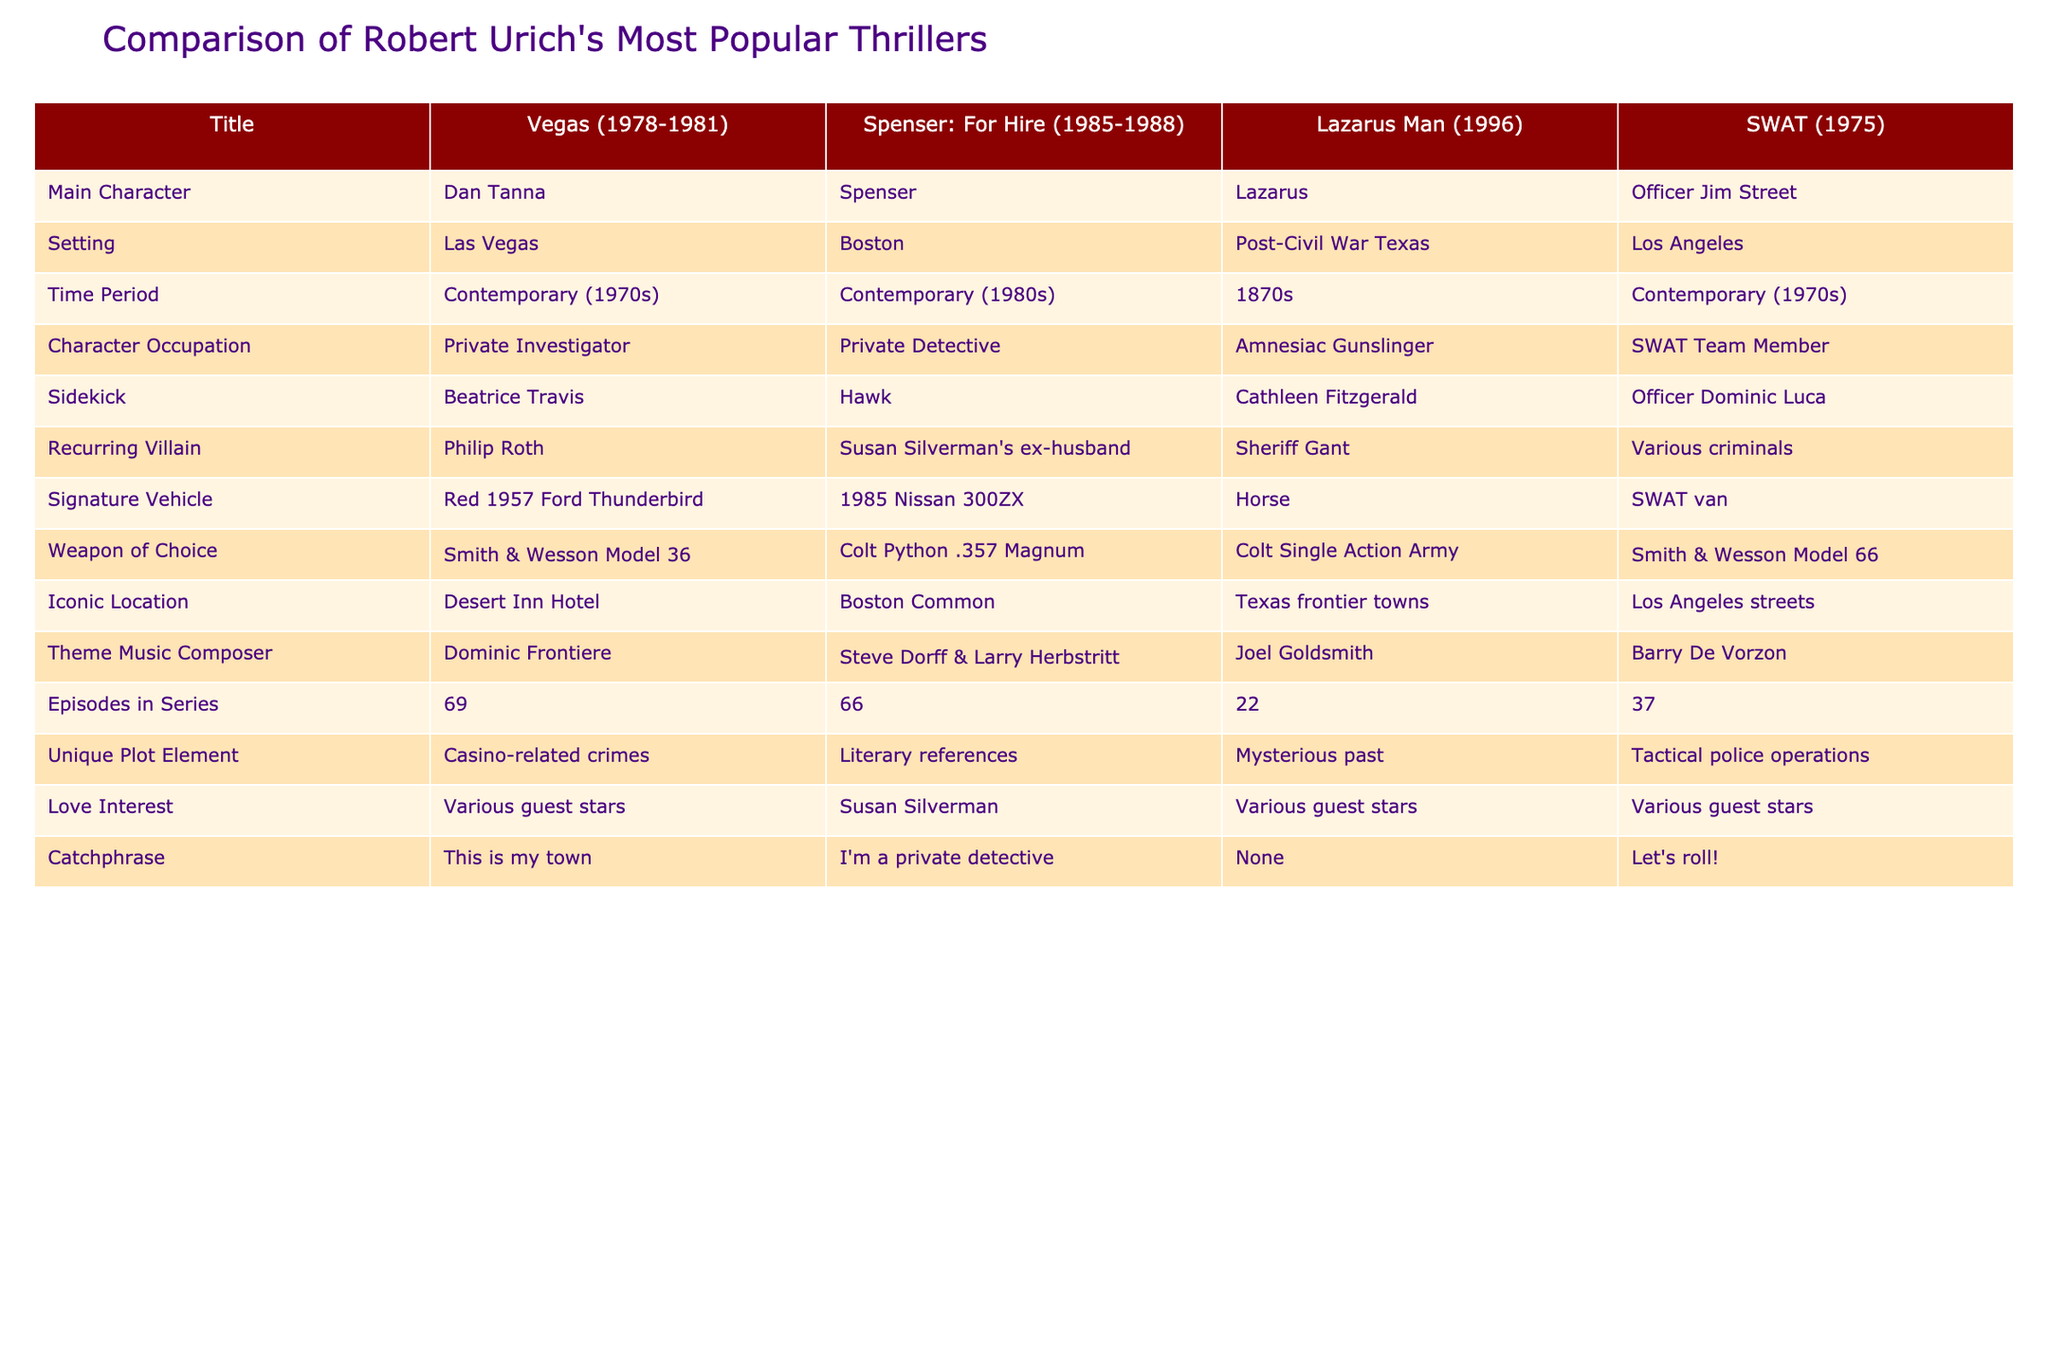What is the main character of "Spenser: For Hire"? Referring to the table, the main character of "Spenser: For Hire" is listed as Spenser.
Answer: Spenser Which show features a character with an amnesiac background? From the table, "Lazarus Man" is noted for having the character Lazarus, who is described as an amnesiac gunslinger.
Answer: Lazarus Man How many episodes are there in "Vegas"? The table shows that "Vegas" had 69 episodes.
Answer: 69 Which series has the unique plot element of casino-related crimes? Looking at the corresponding column for unique plot elements, "Vegas" is identified as having casino-related crimes as its unique plot element.
Answer: Vegas Is the iconic location of "Spenser: For Hire" Boston Common? According to the table, the iconic location for "Spenser: For Hire" is indeed Boston Common, confirming the statement as true.
Answer: Yes What is the average number of episodes for the four shows listed? To find the average, add the episodes together: 69 (Vegas) + 66 (Spenser: For Hire) + 22 (Lazarus Man) + 37 (SWAT) = 194. There are 4 shows, so the average is 194/4 = 48.5.
Answer: 48.5 Which character in the table has a recurring villain named Sheriff Gant? The table indicates that the character Lazarus from "Lazarus Man" has Sheriff Gant as a recurring villain.
Answer: Lazarus What is the weapon of choice for the main character in "SWAT"? The table reveals that Officer Jim Street from "SWAT" uses the Smith & Wesson Model 66 as his weapon of choice.
Answer: Smith & Wesson Model 66 Which show features a character who drives a red 1957 Ford Thunderbird? According to the table, the character Dan Tanna in "Vegas" drives a red 1957 Ford Thunderbird.
Answer: Vegas 